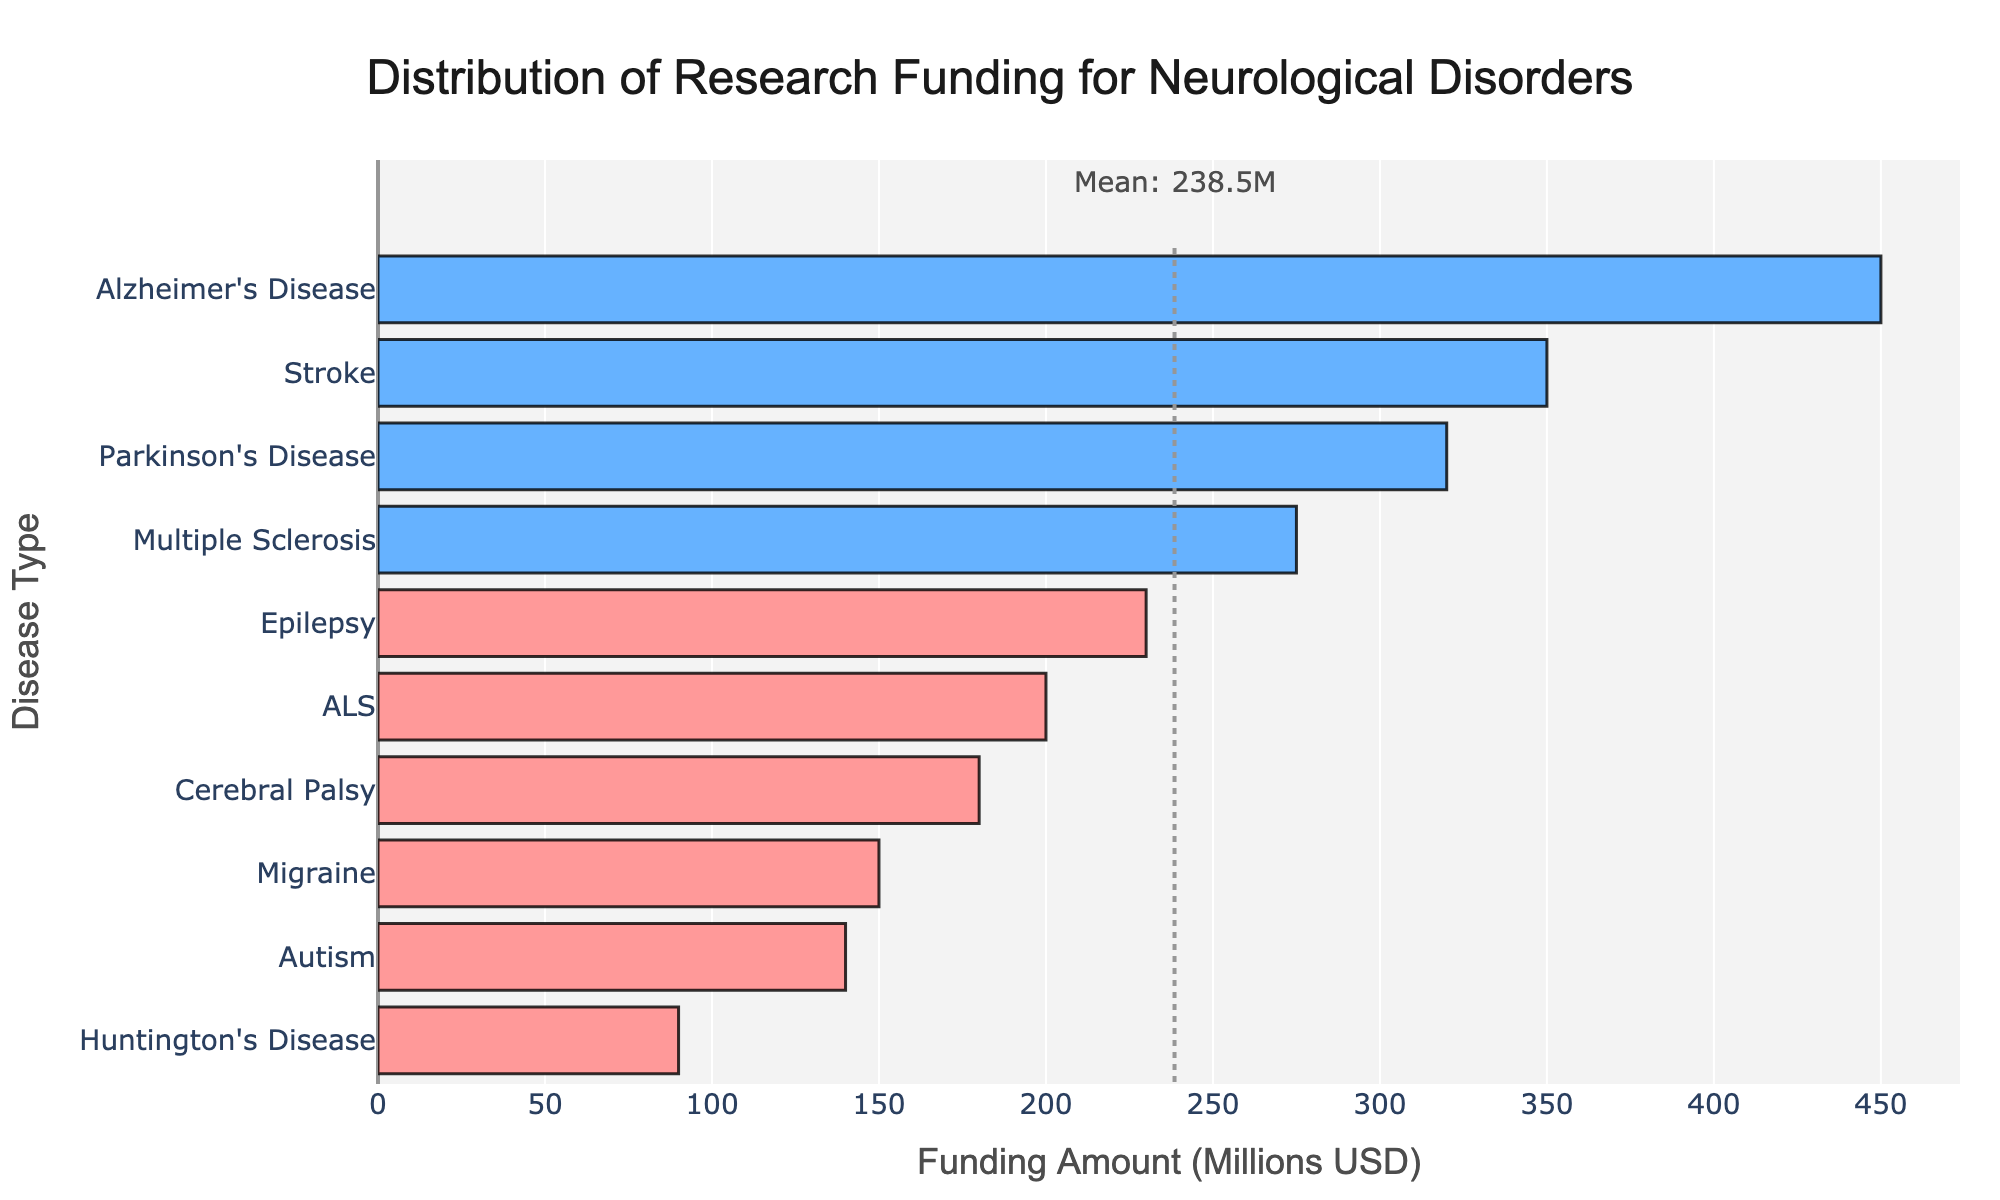Which disease type received the highest research funding? By examining the lengths of the bars, we see that Alzheimer's Disease has the longest bar, indicating the highest funding.
Answer: Alzheimer's Disease Which disease type received the lowest research funding? The shortest bar in the chart belongs to Huntington's Disease, indicating it received the lowest funding.
Answer: Huntington's Disease How much more funding does Parkinson's Disease receive compared to Epilepsy? Parkinson's Disease received 320 million USD, and Epilepsy received 230 million USD. The difference is 320 - 230 = 90 million USD.
Answer: 90 million USD Which neurological disorder's funding is closest to the average funding amount? By looking at the bars, we see that Stroke's funding is closest to the mean, which is marked with a vertical dotted line at approximately 238.5 million USD. Stroke received 350 million USD.
Answer: Stroke What is the total funding amount for ALS and Autism combined? ALS received 200 million USD and Autism received 140 million USD. Their combined funding is 200 + 140 = 340 million USD.
Answer: 340 million USD Which disease has a funding amount above the average but less than 300 million USD? The disorders that are above the average funding (238.5 million USD) but less than 300 million USD, are Parkinson's Disease with 320 million USD and Multiple Sclerosis with 275 million USD.
Answer: Multiple Sclerosis Compare the funding amounts for Stroke and Cerebral Palsy. Which has a higher amount and by how much? Stroke received 350 million USD, and Cerebral Palsy received 180 million USD. The difference is 350 - 180 = 170 million USD.
Answer: Stroke by 170 million USD Identify all the disease types that received research funding below the mean amount. The average funding amount is 238.5 million USD. Comparing all bars below this line, the diseases are Epilepsy, Migraine, ALS, Huntington's Disease, Cerebral Palsy, and Autism.
Answer: Epilepsy, Migraine, ALS, Huntington's Disease, Cerebral Palsy, Autism What is the proportion of funding for Alzheimer's Disease relative to the total funding for all disease types? Alzheimer's Disease received 450 million USD. The total funding amount for all diseases is 450 + 320 + 275 + 230 + 150 + 200 + 90 + 180 + 350 + 140 = 2385 million USD. The proportion is 450/2385 ≈ 0.1886 or 18.86%.
Answer: 18.86% Rank the top three neurological disorders based on their research funding amounts. By comparing the lengths of the bars from longest to shortest, the top three funded disorders are Alzheimer's Disease (450 million USD), Stroke (350 million USD), and Parkinson's Disease (320 million USD).
Answer: Alzheimer's Disease, Stroke, Parkinson's Disease 